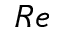Convert formula to latex. <formula><loc_0><loc_0><loc_500><loc_500>R e</formula> 